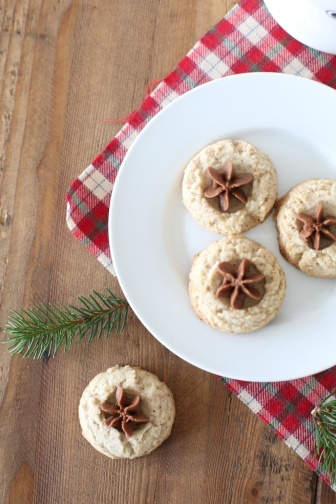What holiday could this setting be for? Given the star anise on the cookies and the red and white checkered napkin, the setting could be for a Christmas celebration. These elements are reminiscent of typical holiday flavors and decorations. 